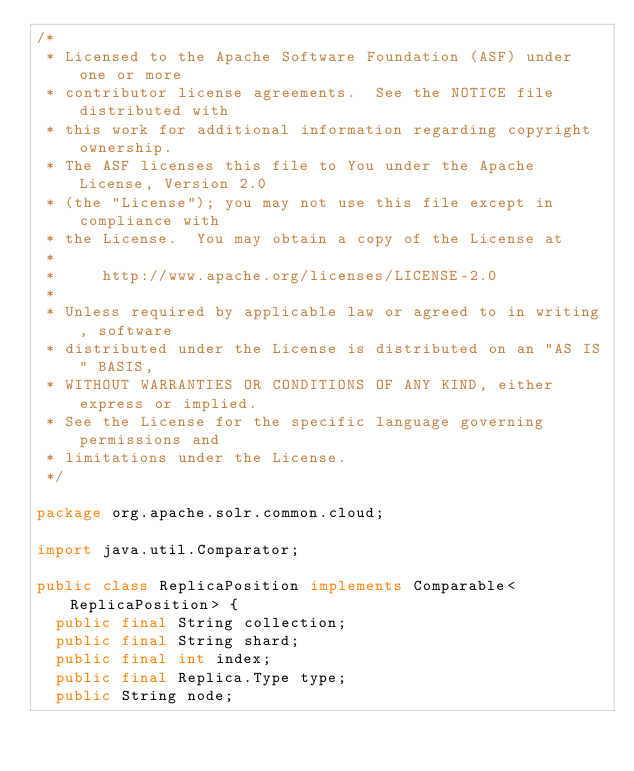Convert code to text. <code><loc_0><loc_0><loc_500><loc_500><_Java_>/*
 * Licensed to the Apache Software Foundation (ASF) under one or more
 * contributor license agreements.  See the NOTICE file distributed with
 * this work for additional information regarding copyright ownership.
 * The ASF licenses this file to You under the Apache License, Version 2.0
 * (the "License"); you may not use this file except in compliance with
 * the License.  You may obtain a copy of the License at
 *
 *     http://www.apache.org/licenses/LICENSE-2.0
 *
 * Unless required by applicable law or agreed to in writing, software
 * distributed under the License is distributed on an "AS IS" BASIS,
 * WITHOUT WARRANTIES OR CONDITIONS OF ANY KIND, either express or implied.
 * See the License for the specific language governing permissions and
 * limitations under the License.
 */

package org.apache.solr.common.cloud;

import java.util.Comparator;

public class ReplicaPosition implements Comparable<ReplicaPosition> {
  public final String collection;
  public final String shard;
  public final int index;
  public final Replica.Type type;
  public String node;
</code> 